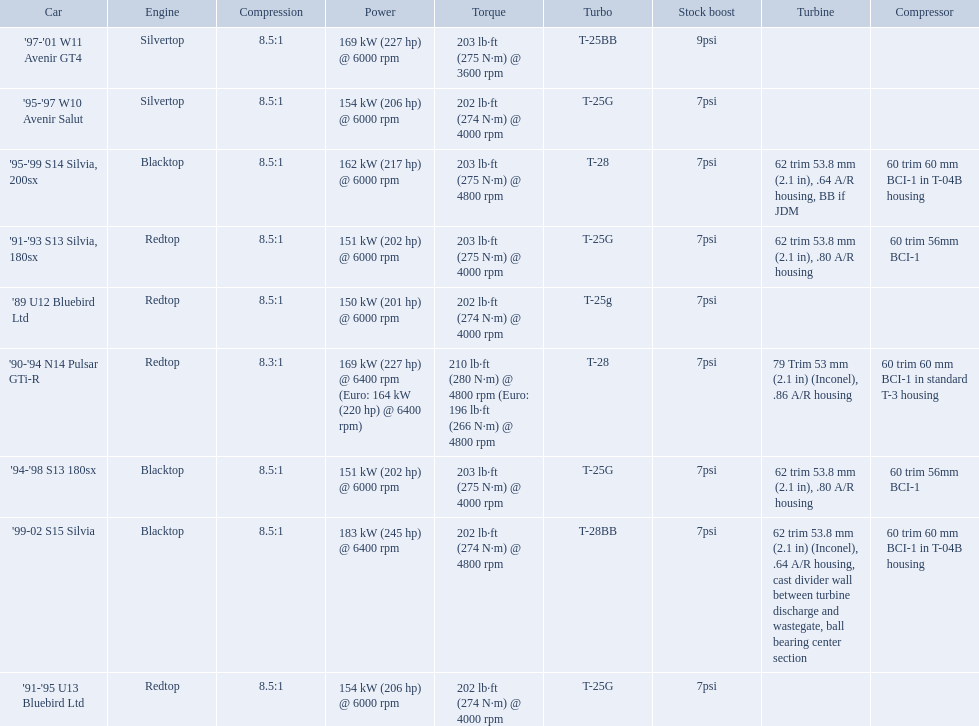What are all the cars? '89 U12 Bluebird Ltd, '91-'95 U13 Bluebird Ltd, '95-'97 W10 Avenir Salut, '97-'01 W11 Avenir GT4, '90-'94 N14 Pulsar GTi-R, '91-'93 S13 Silvia, 180sx, '94-'98 S13 180sx, '95-'99 S14 Silvia, 200sx, '99-02 S15 Silvia. What are their stock boosts? 7psi, 7psi, 7psi, 9psi, 7psi, 7psi, 7psi, 7psi, 7psi. And which car has the highest stock boost? '97-'01 W11 Avenir GT4. Which of the cars uses the redtop engine? '89 U12 Bluebird Ltd, '91-'95 U13 Bluebird Ltd, '90-'94 N14 Pulsar GTi-R, '91-'93 S13 Silvia, 180sx. Of these, has more than 220 horsepower? '90-'94 N14 Pulsar GTi-R. What is the compression ratio of this car? 8.3:1. 